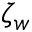Convert formula to latex. <formula><loc_0><loc_0><loc_500><loc_500>\zeta _ { w }</formula> 